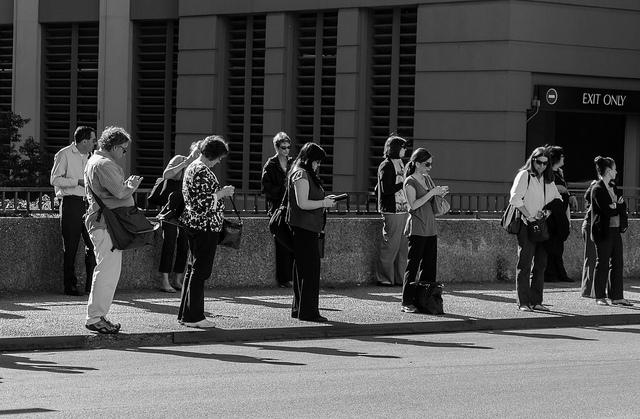What are the people likely doing?

Choices:
A) playing games
B) reading
C) waiting
D) running waiting 